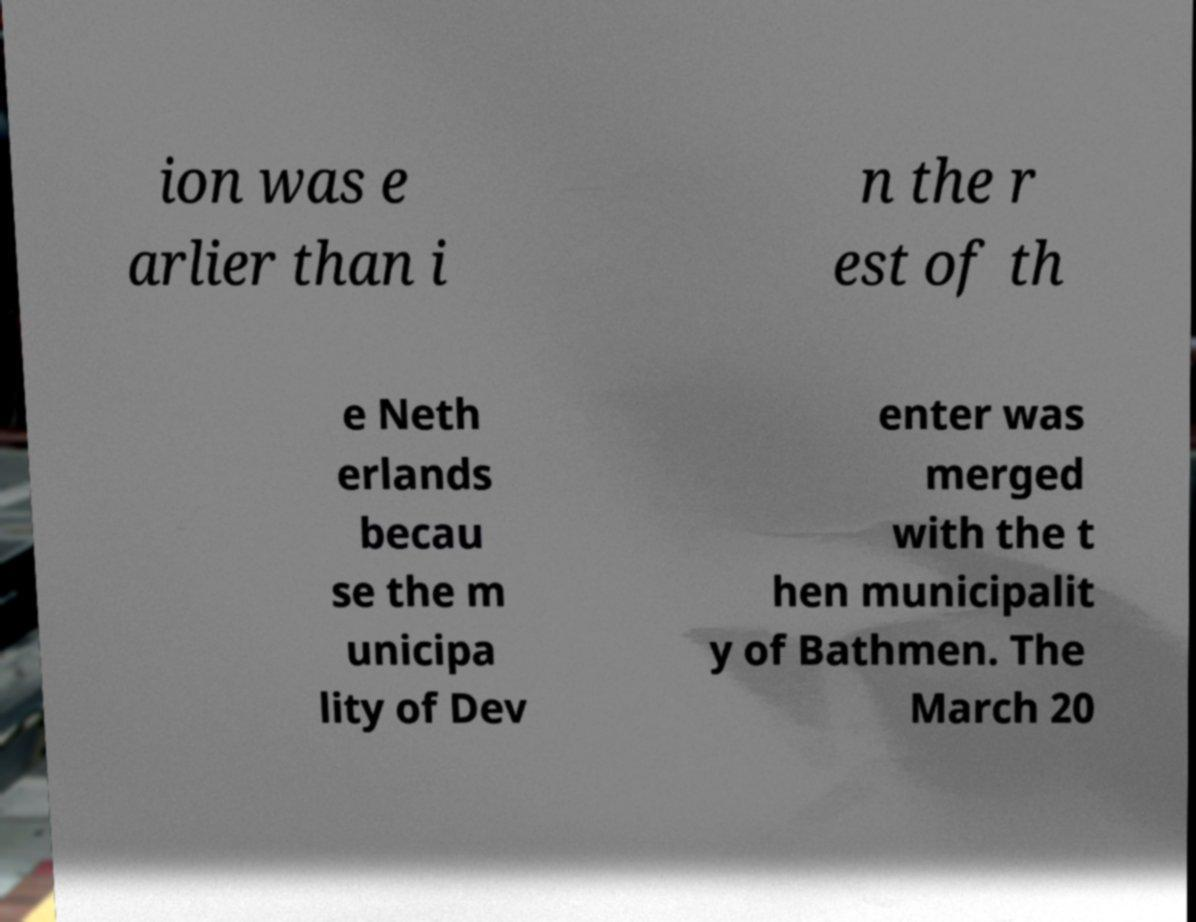There's text embedded in this image that I need extracted. Can you transcribe it verbatim? ion was e arlier than i n the r est of th e Neth erlands becau se the m unicipa lity of Dev enter was merged with the t hen municipalit y of Bathmen. The March 20 